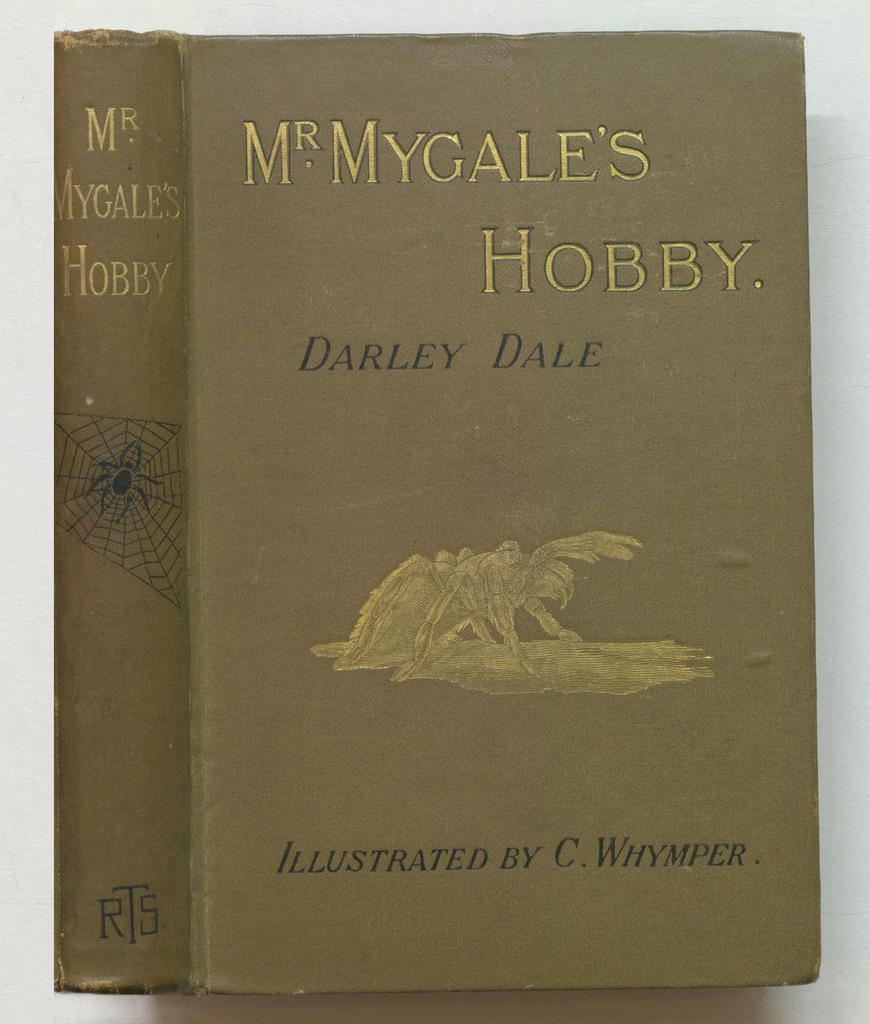<image>
Summarize the visual content of the image. Darley Dale's book was illustrated by C. Whymper. 